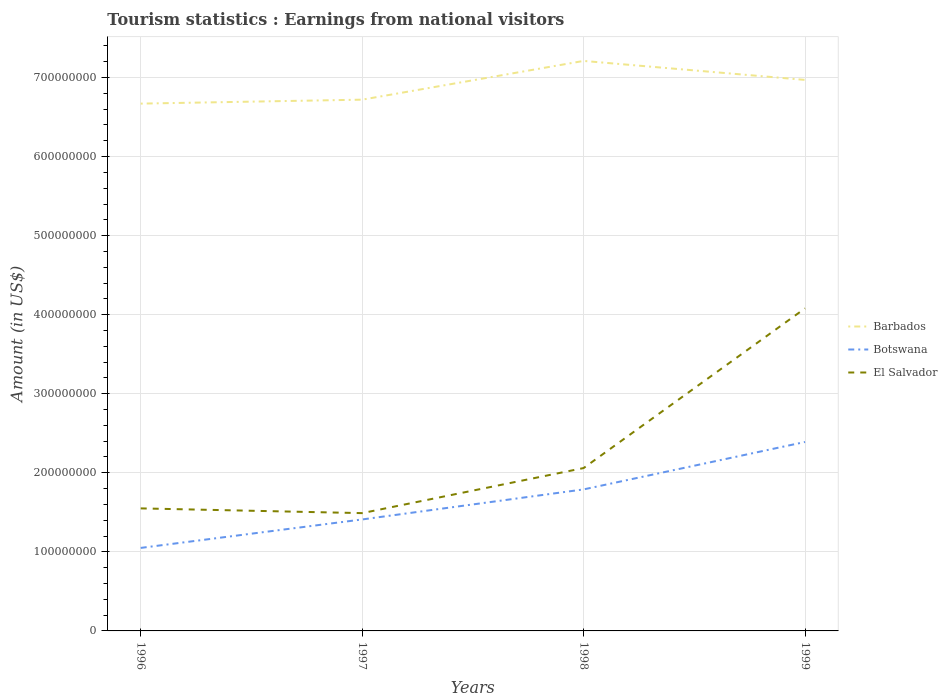Across all years, what is the maximum earnings from national visitors in Botswana?
Provide a short and direct response. 1.05e+08. What is the total earnings from national visitors in Botswana in the graph?
Make the answer very short. -7.40e+07. What is the difference between the highest and the second highest earnings from national visitors in Barbados?
Your answer should be compact. 5.40e+07. What is the difference between the highest and the lowest earnings from national visitors in El Salvador?
Provide a short and direct response. 1. How many lines are there?
Make the answer very short. 3. How many years are there in the graph?
Ensure brevity in your answer.  4. What is the difference between two consecutive major ticks on the Y-axis?
Offer a very short reply. 1.00e+08. Are the values on the major ticks of Y-axis written in scientific E-notation?
Give a very brief answer. No. Does the graph contain any zero values?
Offer a terse response. No. Does the graph contain grids?
Make the answer very short. Yes. Where does the legend appear in the graph?
Your answer should be very brief. Center right. How are the legend labels stacked?
Offer a very short reply. Vertical. What is the title of the graph?
Provide a short and direct response. Tourism statistics : Earnings from national visitors. Does "Ethiopia" appear as one of the legend labels in the graph?
Your answer should be compact. No. What is the label or title of the Y-axis?
Give a very brief answer. Amount (in US$). What is the Amount (in US$) of Barbados in 1996?
Offer a very short reply. 6.67e+08. What is the Amount (in US$) in Botswana in 1996?
Provide a succinct answer. 1.05e+08. What is the Amount (in US$) in El Salvador in 1996?
Keep it short and to the point. 1.55e+08. What is the Amount (in US$) in Barbados in 1997?
Ensure brevity in your answer.  6.72e+08. What is the Amount (in US$) in Botswana in 1997?
Ensure brevity in your answer.  1.41e+08. What is the Amount (in US$) of El Salvador in 1997?
Give a very brief answer. 1.49e+08. What is the Amount (in US$) of Barbados in 1998?
Your response must be concise. 7.21e+08. What is the Amount (in US$) of Botswana in 1998?
Your answer should be compact. 1.79e+08. What is the Amount (in US$) in El Salvador in 1998?
Make the answer very short. 2.06e+08. What is the Amount (in US$) of Barbados in 1999?
Your answer should be compact. 6.97e+08. What is the Amount (in US$) in Botswana in 1999?
Offer a very short reply. 2.39e+08. What is the Amount (in US$) of El Salvador in 1999?
Your response must be concise. 4.08e+08. Across all years, what is the maximum Amount (in US$) of Barbados?
Give a very brief answer. 7.21e+08. Across all years, what is the maximum Amount (in US$) in Botswana?
Your response must be concise. 2.39e+08. Across all years, what is the maximum Amount (in US$) in El Salvador?
Ensure brevity in your answer.  4.08e+08. Across all years, what is the minimum Amount (in US$) of Barbados?
Provide a succinct answer. 6.67e+08. Across all years, what is the minimum Amount (in US$) of Botswana?
Provide a short and direct response. 1.05e+08. Across all years, what is the minimum Amount (in US$) of El Salvador?
Make the answer very short. 1.49e+08. What is the total Amount (in US$) in Barbados in the graph?
Give a very brief answer. 2.76e+09. What is the total Amount (in US$) of Botswana in the graph?
Offer a terse response. 6.64e+08. What is the total Amount (in US$) in El Salvador in the graph?
Keep it short and to the point. 9.18e+08. What is the difference between the Amount (in US$) in Barbados in 1996 and that in 1997?
Provide a succinct answer. -5.00e+06. What is the difference between the Amount (in US$) in Botswana in 1996 and that in 1997?
Offer a terse response. -3.60e+07. What is the difference between the Amount (in US$) in El Salvador in 1996 and that in 1997?
Provide a short and direct response. 6.00e+06. What is the difference between the Amount (in US$) of Barbados in 1996 and that in 1998?
Provide a short and direct response. -5.40e+07. What is the difference between the Amount (in US$) of Botswana in 1996 and that in 1998?
Your response must be concise. -7.40e+07. What is the difference between the Amount (in US$) in El Salvador in 1996 and that in 1998?
Ensure brevity in your answer.  -5.10e+07. What is the difference between the Amount (in US$) of Barbados in 1996 and that in 1999?
Your answer should be compact. -3.00e+07. What is the difference between the Amount (in US$) of Botswana in 1996 and that in 1999?
Your response must be concise. -1.34e+08. What is the difference between the Amount (in US$) in El Salvador in 1996 and that in 1999?
Keep it short and to the point. -2.53e+08. What is the difference between the Amount (in US$) of Barbados in 1997 and that in 1998?
Provide a succinct answer. -4.90e+07. What is the difference between the Amount (in US$) of Botswana in 1997 and that in 1998?
Provide a short and direct response. -3.80e+07. What is the difference between the Amount (in US$) in El Salvador in 1997 and that in 1998?
Give a very brief answer. -5.70e+07. What is the difference between the Amount (in US$) in Barbados in 1997 and that in 1999?
Your response must be concise. -2.50e+07. What is the difference between the Amount (in US$) in Botswana in 1997 and that in 1999?
Ensure brevity in your answer.  -9.80e+07. What is the difference between the Amount (in US$) of El Salvador in 1997 and that in 1999?
Make the answer very short. -2.59e+08. What is the difference between the Amount (in US$) in Barbados in 1998 and that in 1999?
Offer a terse response. 2.40e+07. What is the difference between the Amount (in US$) in Botswana in 1998 and that in 1999?
Ensure brevity in your answer.  -6.00e+07. What is the difference between the Amount (in US$) of El Salvador in 1998 and that in 1999?
Offer a terse response. -2.02e+08. What is the difference between the Amount (in US$) in Barbados in 1996 and the Amount (in US$) in Botswana in 1997?
Provide a succinct answer. 5.26e+08. What is the difference between the Amount (in US$) of Barbados in 1996 and the Amount (in US$) of El Salvador in 1997?
Ensure brevity in your answer.  5.18e+08. What is the difference between the Amount (in US$) in Botswana in 1996 and the Amount (in US$) in El Salvador in 1997?
Your answer should be compact. -4.40e+07. What is the difference between the Amount (in US$) of Barbados in 1996 and the Amount (in US$) of Botswana in 1998?
Your answer should be compact. 4.88e+08. What is the difference between the Amount (in US$) of Barbados in 1996 and the Amount (in US$) of El Salvador in 1998?
Offer a terse response. 4.61e+08. What is the difference between the Amount (in US$) in Botswana in 1996 and the Amount (in US$) in El Salvador in 1998?
Your response must be concise. -1.01e+08. What is the difference between the Amount (in US$) of Barbados in 1996 and the Amount (in US$) of Botswana in 1999?
Your answer should be very brief. 4.28e+08. What is the difference between the Amount (in US$) of Barbados in 1996 and the Amount (in US$) of El Salvador in 1999?
Provide a short and direct response. 2.59e+08. What is the difference between the Amount (in US$) in Botswana in 1996 and the Amount (in US$) in El Salvador in 1999?
Provide a succinct answer. -3.03e+08. What is the difference between the Amount (in US$) of Barbados in 1997 and the Amount (in US$) of Botswana in 1998?
Keep it short and to the point. 4.93e+08. What is the difference between the Amount (in US$) of Barbados in 1997 and the Amount (in US$) of El Salvador in 1998?
Make the answer very short. 4.66e+08. What is the difference between the Amount (in US$) in Botswana in 1997 and the Amount (in US$) in El Salvador in 1998?
Give a very brief answer. -6.50e+07. What is the difference between the Amount (in US$) in Barbados in 1997 and the Amount (in US$) in Botswana in 1999?
Offer a very short reply. 4.33e+08. What is the difference between the Amount (in US$) of Barbados in 1997 and the Amount (in US$) of El Salvador in 1999?
Ensure brevity in your answer.  2.64e+08. What is the difference between the Amount (in US$) in Botswana in 1997 and the Amount (in US$) in El Salvador in 1999?
Provide a succinct answer. -2.67e+08. What is the difference between the Amount (in US$) in Barbados in 1998 and the Amount (in US$) in Botswana in 1999?
Provide a short and direct response. 4.82e+08. What is the difference between the Amount (in US$) of Barbados in 1998 and the Amount (in US$) of El Salvador in 1999?
Give a very brief answer. 3.13e+08. What is the difference between the Amount (in US$) of Botswana in 1998 and the Amount (in US$) of El Salvador in 1999?
Your answer should be compact. -2.29e+08. What is the average Amount (in US$) of Barbados per year?
Keep it short and to the point. 6.89e+08. What is the average Amount (in US$) of Botswana per year?
Offer a very short reply. 1.66e+08. What is the average Amount (in US$) in El Salvador per year?
Keep it short and to the point. 2.30e+08. In the year 1996, what is the difference between the Amount (in US$) of Barbados and Amount (in US$) of Botswana?
Offer a terse response. 5.62e+08. In the year 1996, what is the difference between the Amount (in US$) in Barbados and Amount (in US$) in El Salvador?
Ensure brevity in your answer.  5.12e+08. In the year 1996, what is the difference between the Amount (in US$) of Botswana and Amount (in US$) of El Salvador?
Your response must be concise. -5.00e+07. In the year 1997, what is the difference between the Amount (in US$) in Barbados and Amount (in US$) in Botswana?
Offer a terse response. 5.31e+08. In the year 1997, what is the difference between the Amount (in US$) in Barbados and Amount (in US$) in El Salvador?
Your answer should be very brief. 5.23e+08. In the year 1997, what is the difference between the Amount (in US$) in Botswana and Amount (in US$) in El Salvador?
Give a very brief answer. -8.00e+06. In the year 1998, what is the difference between the Amount (in US$) in Barbados and Amount (in US$) in Botswana?
Your response must be concise. 5.42e+08. In the year 1998, what is the difference between the Amount (in US$) in Barbados and Amount (in US$) in El Salvador?
Keep it short and to the point. 5.15e+08. In the year 1998, what is the difference between the Amount (in US$) in Botswana and Amount (in US$) in El Salvador?
Offer a very short reply. -2.70e+07. In the year 1999, what is the difference between the Amount (in US$) of Barbados and Amount (in US$) of Botswana?
Offer a very short reply. 4.58e+08. In the year 1999, what is the difference between the Amount (in US$) of Barbados and Amount (in US$) of El Salvador?
Provide a succinct answer. 2.89e+08. In the year 1999, what is the difference between the Amount (in US$) in Botswana and Amount (in US$) in El Salvador?
Your response must be concise. -1.69e+08. What is the ratio of the Amount (in US$) in Barbados in 1996 to that in 1997?
Make the answer very short. 0.99. What is the ratio of the Amount (in US$) of Botswana in 1996 to that in 1997?
Your response must be concise. 0.74. What is the ratio of the Amount (in US$) in El Salvador in 1996 to that in 1997?
Your answer should be very brief. 1.04. What is the ratio of the Amount (in US$) in Barbados in 1996 to that in 1998?
Give a very brief answer. 0.93. What is the ratio of the Amount (in US$) in Botswana in 1996 to that in 1998?
Provide a short and direct response. 0.59. What is the ratio of the Amount (in US$) in El Salvador in 1996 to that in 1998?
Provide a succinct answer. 0.75. What is the ratio of the Amount (in US$) in Barbados in 1996 to that in 1999?
Ensure brevity in your answer.  0.96. What is the ratio of the Amount (in US$) in Botswana in 1996 to that in 1999?
Offer a terse response. 0.44. What is the ratio of the Amount (in US$) in El Salvador in 1996 to that in 1999?
Your answer should be compact. 0.38. What is the ratio of the Amount (in US$) in Barbados in 1997 to that in 1998?
Give a very brief answer. 0.93. What is the ratio of the Amount (in US$) of Botswana in 1997 to that in 1998?
Your answer should be very brief. 0.79. What is the ratio of the Amount (in US$) in El Salvador in 1997 to that in 1998?
Offer a terse response. 0.72. What is the ratio of the Amount (in US$) in Barbados in 1997 to that in 1999?
Your answer should be very brief. 0.96. What is the ratio of the Amount (in US$) in Botswana in 1997 to that in 1999?
Give a very brief answer. 0.59. What is the ratio of the Amount (in US$) in El Salvador in 1997 to that in 1999?
Ensure brevity in your answer.  0.37. What is the ratio of the Amount (in US$) in Barbados in 1998 to that in 1999?
Your answer should be compact. 1.03. What is the ratio of the Amount (in US$) of Botswana in 1998 to that in 1999?
Offer a terse response. 0.75. What is the ratio of the Amount (in US$) of El Salvador in 1998 to that in 1999?
Provide a succinct answer. 0.5. What is the difference between the highest and the second highest Amount (in US$) of Barbados?
Make the answer very short. 2.40e+07. What is the difference between the highest and the second highest Amount (in US$) of Botswana?
Make the answer very short. 6.00e+07. What is the difference between the highest and the second highest Amount (in US$) in El Salvador?
Give a very brief answer. 2.02e+08. What is the difference between the highest and the lowest Amount (in US$) in Barbados?
Ensure brevity in your answer.  5.40e+07. What is the difference between the highest and the lowest Amount (in US$) in Botswana?
Offer a very short reply. 1.34e+08. What is the difference between the highest and the lowest Amount (in US$) in El Salvador?
Ensure brevity in your answer.  2.59e+08. 